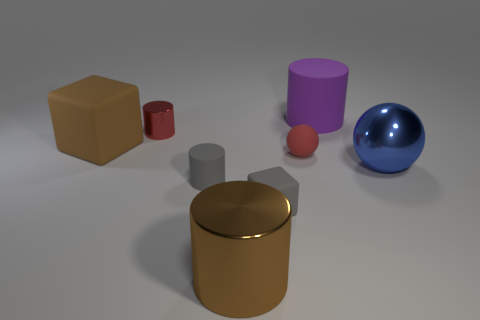Subtract 1 cylinders. How many cylinders are left? 3 Add 2 tiny purple metallic spheres. How many objects exist? 10 Subtract all balls. How many objects are left? 6 Add 6 green rubber spheres. How many green rubber spheres exist? 6 Subtract 1 brown blocks. How many objects are left? 7 Subtract all brown blocks. Subtract all blocks. How many objects are left? 5 Add 1 gray rubber cubes. How many gray rubber cubes are left? 2 